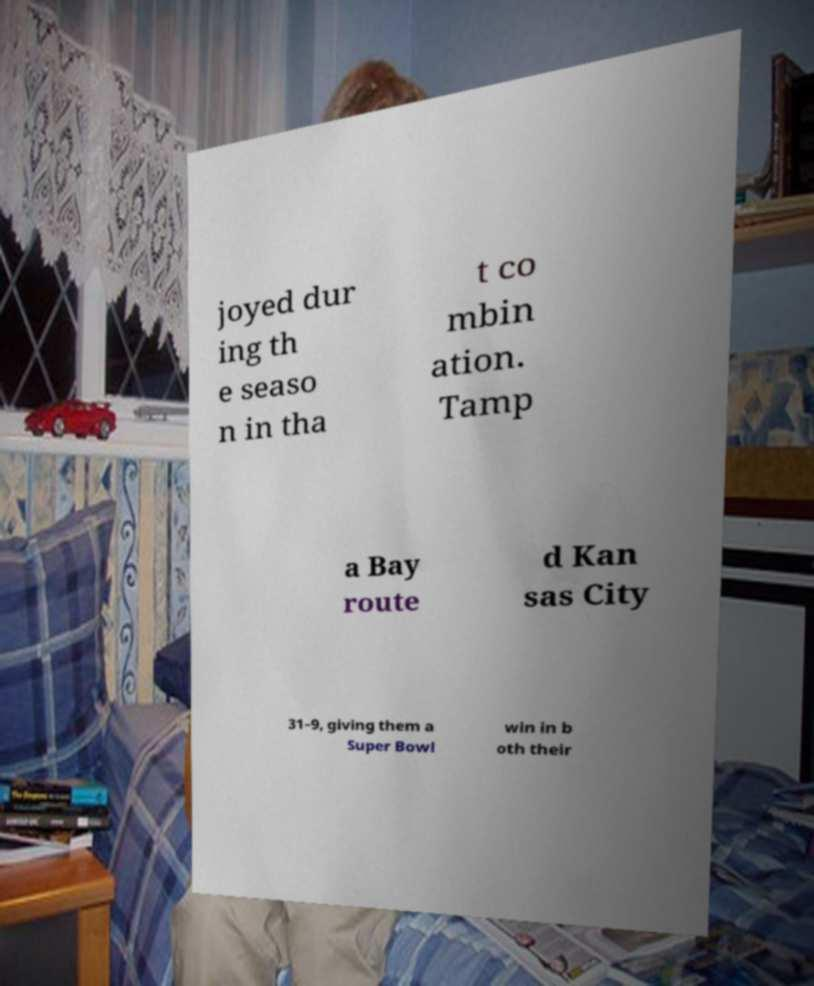Can you accurately transcribe the text from the provided image for me? joyed dur ing th e seaso n in tha t co mbin ation. Tamp a Bay route d Kan sas City 31–9, giving them a Super Bowl win in b oth their 